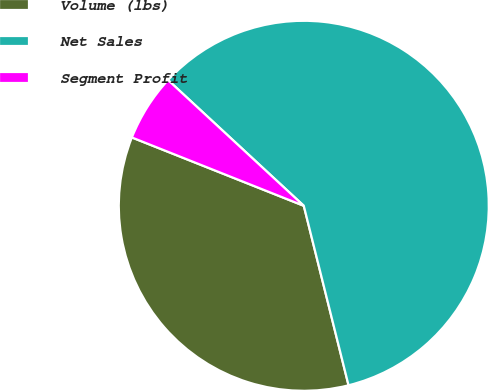<chart> <loc_0><loc_0><loc_500><loc_500><pie_chart><fcel>Volume (lbs)<fcel>Net Sales<fcel>Segment Profit<nl><fcel>34.91%<fcel>59.22%<fcel>5.87%<nl></chart> 